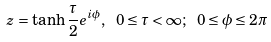<formula> <loc_0><loc_0><loc_500><loc_500>z = \tanh \frac { \tau } { 2 } e ^ { i \phi } , \ 0 \leq \tau < \infty ; \ 0 \leq \phi \leq 2 \pi</formula> 